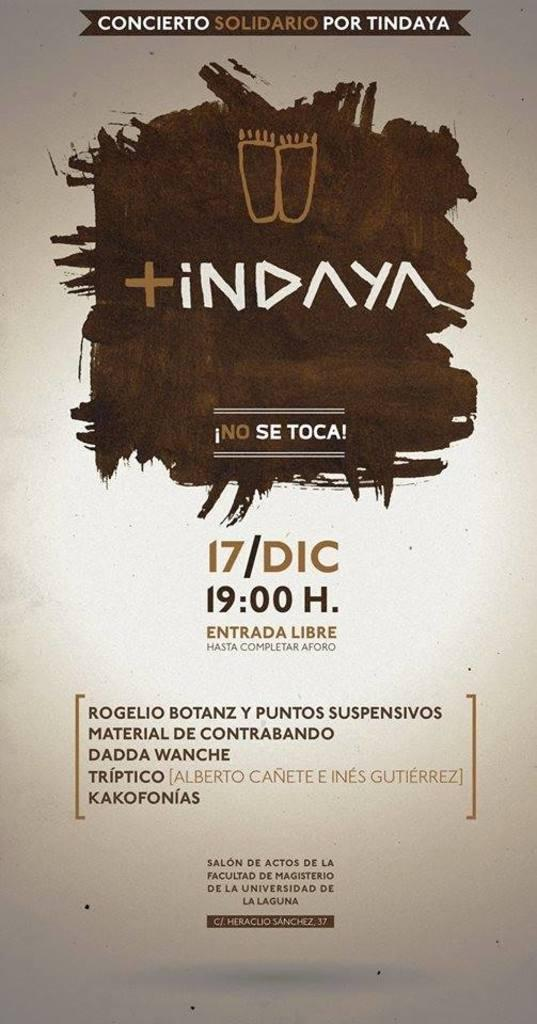<image>
Describe the image concisely. an image of a showtime poster for a show called 'Tindaya' 